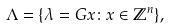<formula> <loc_0><loc_0><loc_500><loc_500>\Lambda = \{ \lambda = G x \colon x \in \mathbb { Z } ^ { n } \} ,</formula> 